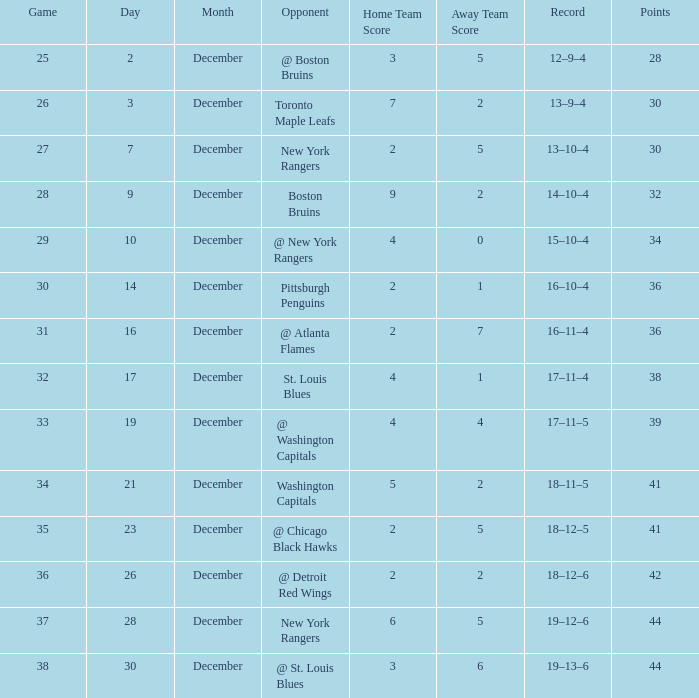What game has a record of 14-10-4 and less than 32 points? None. 